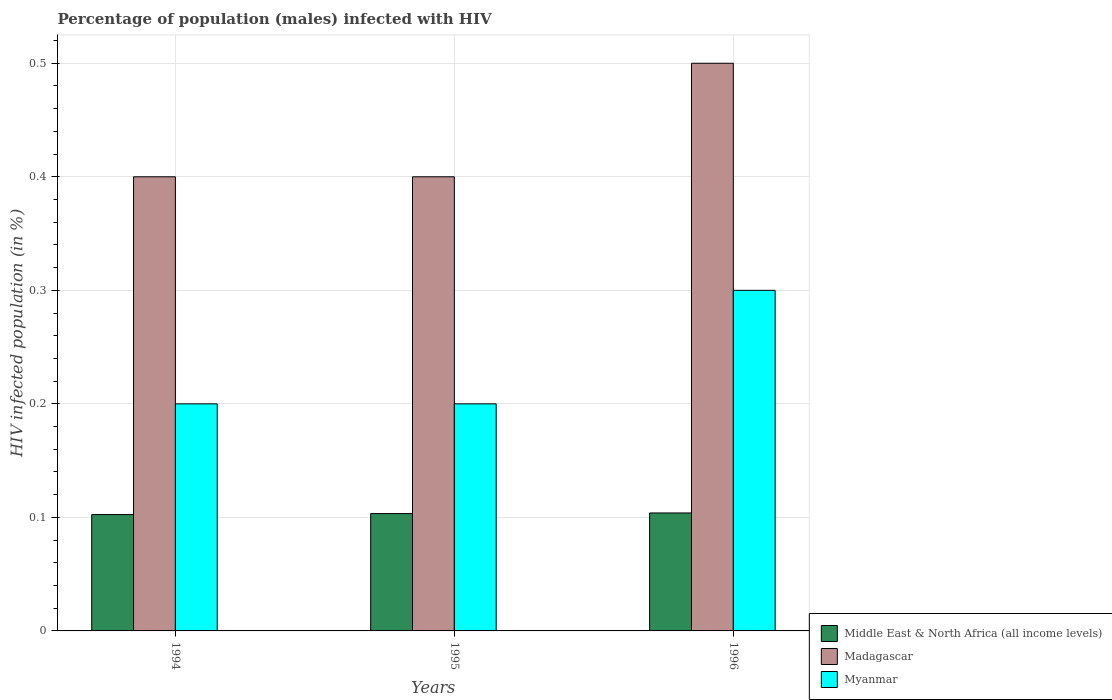Are the number of bars per tick equal to the number of legend labels?
Your answer should be very brief. Yes. Are the number of bars on each tick of the X-axis equal?
Offer a very short reply. Yes. How many bars are there on the 1st tick from the left?
Keep it short and to the point. 3. What is the label of the 1st group of bars from the left?
Keep it short and to the point. 1994. What is the percentage of HIV infected male population in Middle East & North Africa (all income levels) in 1996?
Provide a short and direct response. 0.1. Across all years, what is the maximum percentage of HIV infected male population in Middle East & North Africa (all income levels)?
Your answer should be compact. 0.1. Across all years, what is the minimum percentage of HIV infected male population in Middle East & North Africa (all income levels)?
Keep it short and to the point. 0.1. In which year was the percentage of HIV infected male population in Madagascar maximum?
Ensure brevity in your answer.  1996. In which year was the percentage of HIV infected male population in Middle East & North Africa (all income levels) minimum?
Your answer should be compact. 1994. What is the difference between the percentage of HIV infected male population in Middle East & North Africa (all income levels) in 1994 and that in 1995?
Keep it short and to the point. -0. What is the difference between the percentage of HIV infected male population in Middle East & North Africa (all income levels) in 1994 and the percentage of HIV infected male population in Madagascar in 1995?
Provide a short and direct response. -0.3. What is the average percentage of HIV infected male population in Myanmar per year?
Keep it short and to the point. 0.23. In the year 1994, what is the difference between the percentage of HIV infected male population in Middle East & North Africa (all income levels) and percentage of HIV infected male population in Myanmar?
Give a very brief answer. -0.1. What is the ratio of the percentage of HIV infected male population in Middle East & North Africa (all income levels) in 1995 to that in 1996?
Your answer should be very brief. 0.99. Is the difference between the percentage of HIV infected male population in Middle East & North Africa (all income levels) in 1994 and 1996 greater than the difference between the percentage of HIV infected male population in Myanmar in 1994 and 1996?
Keep it short and to the point. Yes. What is the difference between the highest and the second highest percentage of HIV infected male population in Myanmar?
Offer a very short reply. 0.1. What is the difference between the highest and the lowest percentage of HIV infected male population in Middle East & North Africa (all income levels)?
Provide a succinct answer. 0. In how many years, is the percentage of HIV infected male population in Madagascar greater than the average percentage of HIV infected male population in Madagascar taken over all years?
Your response must be concise. 1. What does the 2nd bar from the left in 1996 represents?
Your answer should be very brief. Madagascar. What does the 2nd bar from the right in 1994 represents?
Ensure brevity in your answer.  Madagascar. How many bars are there?
Make the answer very short. 9. Are all the bars in the graph horizontal?
Ensure brevity in your answer.  No. How many years are there in the graph?
Ensure brevity in your answer.  3. What is the difference between two consecutive major ticks on the Y-axis?
Your answer should be compact. 0.1. Does the graph contain any zero values?
Offer a very short reply. No. Does the graph contain grids?
Provide a short and direct response. Yes. How many legend labels are there?
Offer a very short reply. 3. What is the title of the graph?
Your response must be concise. Percentage of population (males) infected with HIV. Does "Channel Islands" appear as one of the legend labels in the graph?
Offer a very short reply. No. What is the label or title of the X-axis?
Give a very brief answer. Years. What is the label or title of the Y-axis?
Offer a very short reply. HIV infected population (in %). What is the HIV infected population (in %) of Middle East & North Africa (all income levels) in 1994?
Your answer should be compact. 0.1. What is the HIV infected population (in %) of Madagascar in 1994?
Your response must be concise. 0.4. What is the HIV infected population (in %) in Myanmar in 1994?
Make the answer very short. 0.2. What is the HIV infected population (in %) of Middle East & North Africa (all income levels) in 1995?
Offer a very short reply. 0.1. What is the HIV infected population (in %) of Middle East & North Africa (all income levels) in 1996?
Make the answer very short. 0.1. What is the HIV infected population (in %) in Madagascar in 1996?
Give a very brief answer. 0.5. What is the HIV infected population (in %) of Myanmar in 1996?
Your answer should be very brief. 0.3. Across all years, what is the maximum HIV infected population (in %) of Middle East & North Africa (all income levels)?
Make the answer very short. 0.1. Across all years, what is the maximum HIV infected population (in %) in Myanmar?
Give a very brief answer. 0.3. Across all years, what is the minimum HIV infected population (in %) of Middle East & North Africa (all income levels)?
Keep it short and to the point. 0.1. What is the total HIV infected population (in %) of Middle East & North Africa (all income levels) in the graph?
Give a very brief answer. 0.31. What is the total HIV infected population (in %) in Myanmar in the graph?
Your answer should be compact. 0.7. What is the difference between the HIV infected population (in %) of Middle East & North Africa (all income levels) in 1994 and that in 1995?
Provide a short and direct response. -0. What is the difference between the HIV infected population (in %) in Middle East & North Africa (all income levels) in 1994 and that in 1996?
Give a very brief answer. -0. What is the difference between the HIV infected population (in %) of Middle East & North Africa (all income levels) in 1995 and that in 1996?
Give a very brief answer. -0. What is the difference between the HIV infected population (in %) of Middle East & North Africa (all income levels) in 1994 and the HIV infected population (in %) of Madagascar in 1995?
Provide a succinct answer. -0.3. What is the difference between the HIV infected population (in %) of Middle East & North Africa (all income levels) in 1994 and the HIV infected population (in %) of Myanmar in 1995?
Ensure brevity in your answer.  -0.1. What is the difference between the HIV infected population (in %) of Middle East & North Africa (all income levels) in 1994 and the HIV infected population (in %) of Madagascar in 1996?
Offer a terse response. -0.4. What is the difference between the HIV infected population (in %) of Middle East & North Africa (all income levels) in 1994 and the HIV infected population (in %) of Myanmar in 1996?
Make the answer very short. -0.2. What is the difference between the HIV infected population (in %) in Madagascar in 1994 and the HIV infected population (in %) in Myanmar in 1996?
Provide a short and direct response. 0.1. What is the difference between the HIV infected population (in %) in Middle East & North Africa (all income levels) in 1995 and the HIV infected population (in %) in Madagascar in 1996?
Give a very brief answer. -0.4. What is the difference between the HIV infected population (in %) in Middle East & North Africa (all income levels) in 1995 and the HIV infected population (in %) in Myanmar in 1996?
Offer a very short reply. -0.2. What is the difference between the HIV infected population (in %) of Madagascar in 1995 and the HIV infected population (in %) of Myanmar in 1996?
Your response must be concise. 0.1. What is the average HIV infected population (in %) in Middle East & North Africa (all income levels) per year?
Ensure brevity in your answer.  0.1. What is the average HIV infected population (in %) in Madagascar per year?
Your answer should be very brief. 0.43. What is the average HIV infected population (in %) of Myanmar per year?
Provide a succinct answer. 0.23. In the year 1994, what is the difference between the HIV infected population (in %) of Middle East & North Africa (all income levels) and HIV infected population (in %) of Madagascar?
Provide a short and direct response. -0.3. In the year 1994, what is the difference between the HIV infected population (in %) in Middle East & North Africa (all income levels) and HIV infected population (in %) in Myanmar?
Provide a succinct answer. -0.1. In the year 1994, what is the difference between the HIV infected population (in %) of Madagascar and HIV infected population (in %) of Myanmar?
Make the answer very short. 0.2. In the year 1995, what is the difference between the HIV infected population (in %) of Middle East & North Africa (all income levels) and HIV infected population (in %) of Madagascar?
Provide a short and direct response. -0.3. In the year 1995, what is the difference between the HIV infected population (in %) in Middle East & North Africa (all income levels) and HIV infected population (in %) in Myanmar?
Your response must be concise. -0.1. In the year 1995, what is the difference between the HIV infected population (in %) in Madagascar and HIV infected population (in %) in Myanmar?
Offer a very short reply. 0.2. In the year 1996, what is the difference between the HIV infected population (in %) in Middle East & North Africa (all income levels) and HIV infected population (in %) in Madagascar?
Make the answer very short. -0.4. In the year 1996, what is the difference between the HIV infected population (in %) of Middle East & North Africa (all income levels) and HIV infected population (in %) of Myanmar?
Ensure brevity in your answer.  -0.2. What is the ratio of the HIV infected population (in %) of Madagascar in 1994 to that in 1995?
Keep it short and to the point. 1. What is the ratio of the HIV infected population (in %) in Myanmar in 1994 to that in 1995?
Your response must be concise. 1. What is the ratio of the HIV infected population (in %) of Middle East & North Africa (all income levels) in 1994 to that in 1996?
Ensure brevity in your answer.  0.99. What is the ratio of the HIV infected population (in %) of Madagascar in 1994 to that in 1996?
Offer a terse response. 0.8. What is the ratio of the HIV infected population (in %) in Myanmar in 1994 to that in 1996?
Keep it short and to the point. 0.67. What is the ratio of the HIV infected population (in %) in Madagascar in 1995 to that in 1996?
Your answer should be compact. 0.8. What is the difference between the highest and the second highest HIV infected population (in %) in Myanmar?
Your answer should be compact. 0.1. What is the difference between the highest and the lowest HIV infected population (in %) of Middle East & North Africa (all income levels)?
Offer a terse response. 0. What is the difference between the highest and the lowest HIV infected population (in %) of Myanmar?
Provide a short and direct response. 0.1. 